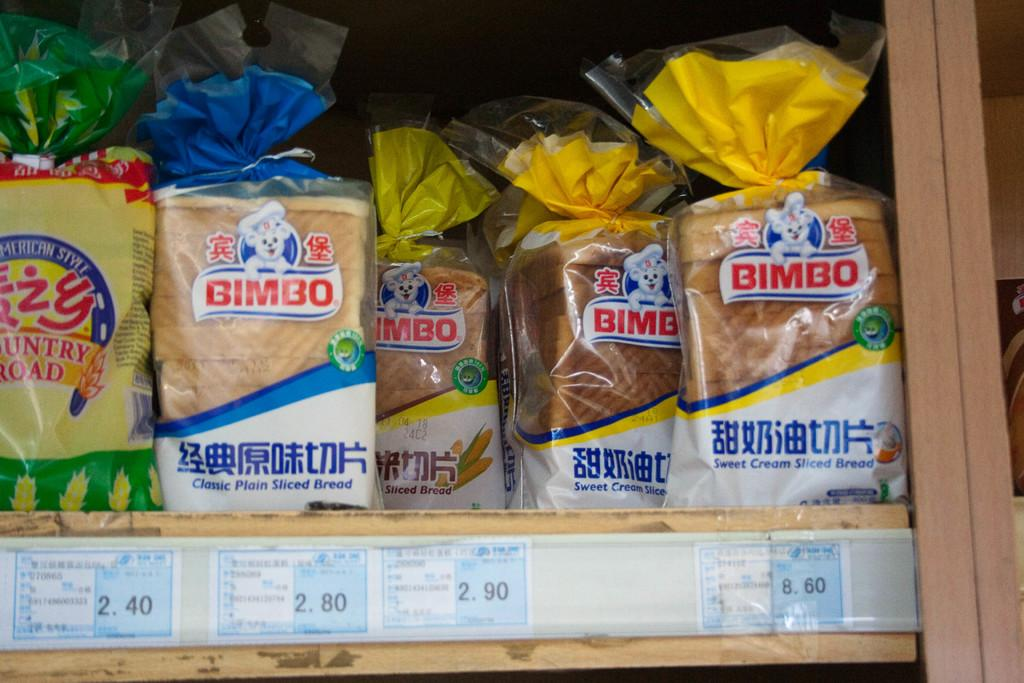What type of food items are visible in the image? There are bread packets in the image. Where are the bread packets located? The bread packets are in a rack. What else can be seen in the image besides the bread packets? There are posters with text in the image. What type of cast can be seen on the bread packets in the image? There is no cast present on the bread packets in the image. 